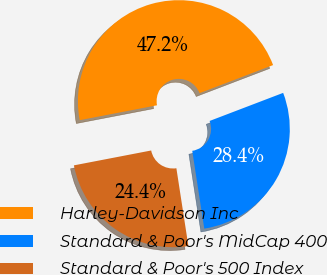Convert chart to OTSL. <chart><loc_0><loc_0><loc_500><loc_500><pie_chart><fcel>Harley-Davidson Inc<fcel>Standard & Poor's MidCap 400<fcel>Standard & Poor's 500 Index<nl><fcel>47.22%<fcel>28.37%<fcel>24.41%<nl></chart> 